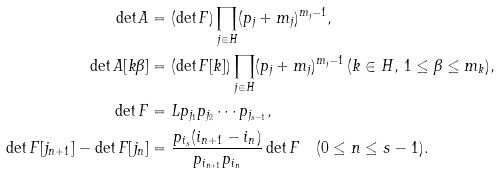Convert formula to latex. <formula><loc_0><loc_0><loc_500><loc_500>\det A & = ( \det F ) \prod _ { j \in H } ( p _ { j } + m _ { j } ) ^ { m _ { j } - 1 } , \\ \det A [ k \beta ] & = ( \det F [ k ] ) \prod _ { j \in H } ( p _ { j } + m _ { j } ) ^ { m _ { j } - 1 } \, ( k \in H , \, 1 \leq \beta \leq m _ { k } ) , \\ \det F & = L p _ { j _ { 1 } } p _ { j _ { 2 } } \cdots p _ { j _ { s - 1 } } , \\ \det F [ j _ { n + 1 } ] - \det F [ j _ { n } ] & = \frac { p _ { i _ { s } } ( i _ { n + 1 } - i _ { n } ) } { p _ { i _ { n + 1 } } p _ { i _ { n } } } \det F \quad ( 0 \leq n \leq s - 1 ) .</formula> 